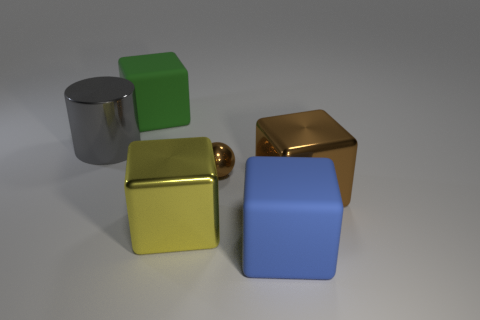Do the big metallic block to the left of the small thing and the large cylinder have the same color?
Your answer should be very brief. No. How many objects are either big blue matte cylinders or large metallic cubes on the right side of the large yellow metal cube?
Provide a succinct answer. 1. There is a large rubber object in front of the gray shiny cylinder; is its shape the same as the brown shiny object behind the big brown metal thing?
Make the answer very short. No. Is there anything else that has the same color as the ball?
Provide a short and direct response. Yes. The yellow object that is made of the same material as the tiny ball is what shape?
Make the answer very short. Cube. What material is the cube that is both to the right of the small brown shiny object and behind the blue thing?
Make the answer very short. Metal. Are there any other things that are the same size as the yellow metal block?
Offer a very short reply. Yes. Do the small metal ball and the big metal cylinder have the same color?
Your answer should be compact. No. There is a thing that is the same color as the small ball; what is its shape?
Offer a terse response. Cube. What number of large gray things are the same shape as the big green matte object?
Your response must be concise. 0. 